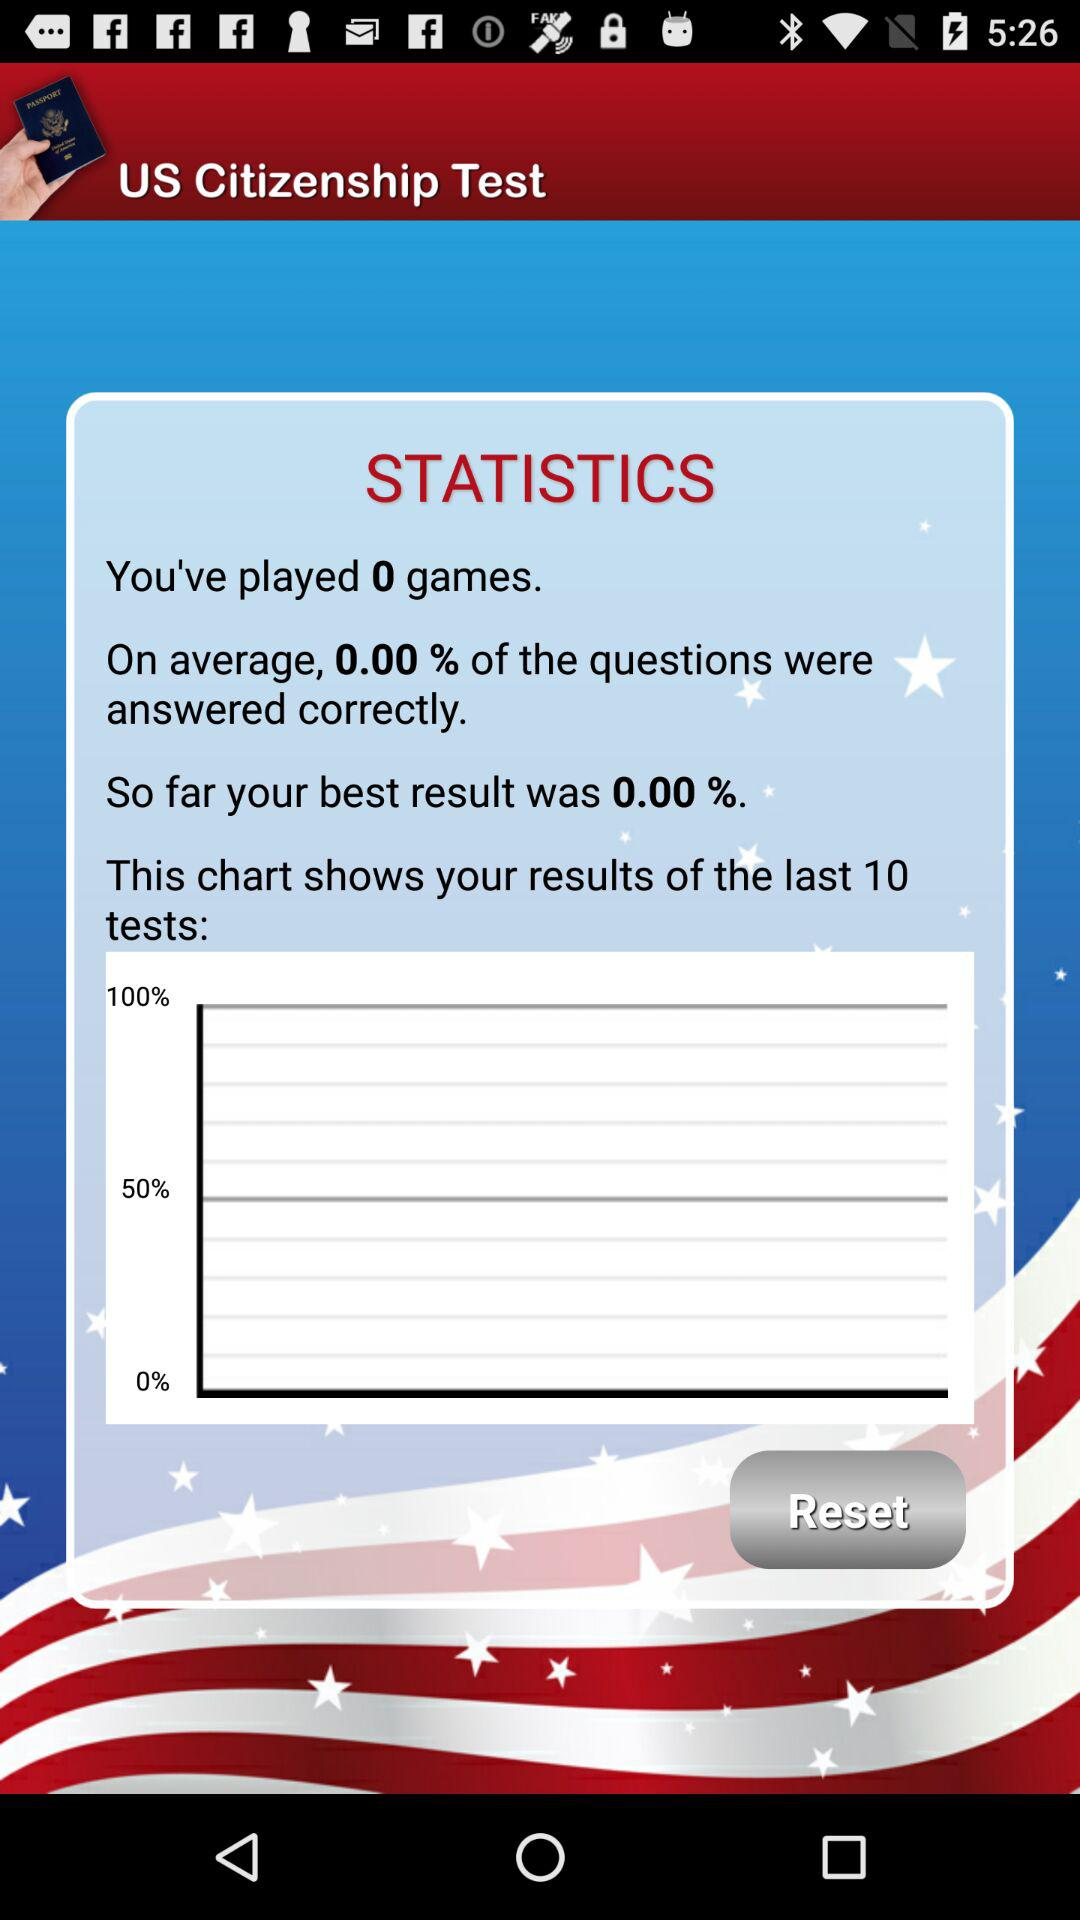What is the application name? The application name is "US Citizenship Test". 